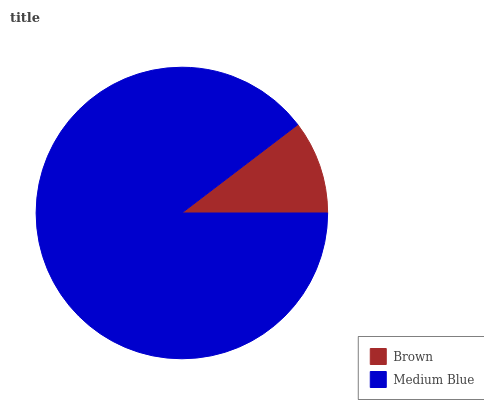Is Brown the minimum?
Answer yes or no. Yes. Is Medium Blue the maximum?
Answer yes or no. Yes. Is Medium Blue the minimum?
Answer yes or no. No. Is Medium Blue greater than Brown?
Answer yes or no. Yes. Is Brown less than Medium Blue?
Answer yes or no. Yes. Is Brown greater than Medium Blue?
Answer yes or no. No. Is Medium Blue less than Brown?
Answer yes or no. No. Is Medium Blue the high median?
Answer yes or no. Yes. Is Brown the low median?
Answer yes or no. Yes. Is Brown the high median?
Answer yes or no. No. Is Medium Blue the low median?
Answer yes or no. No. 